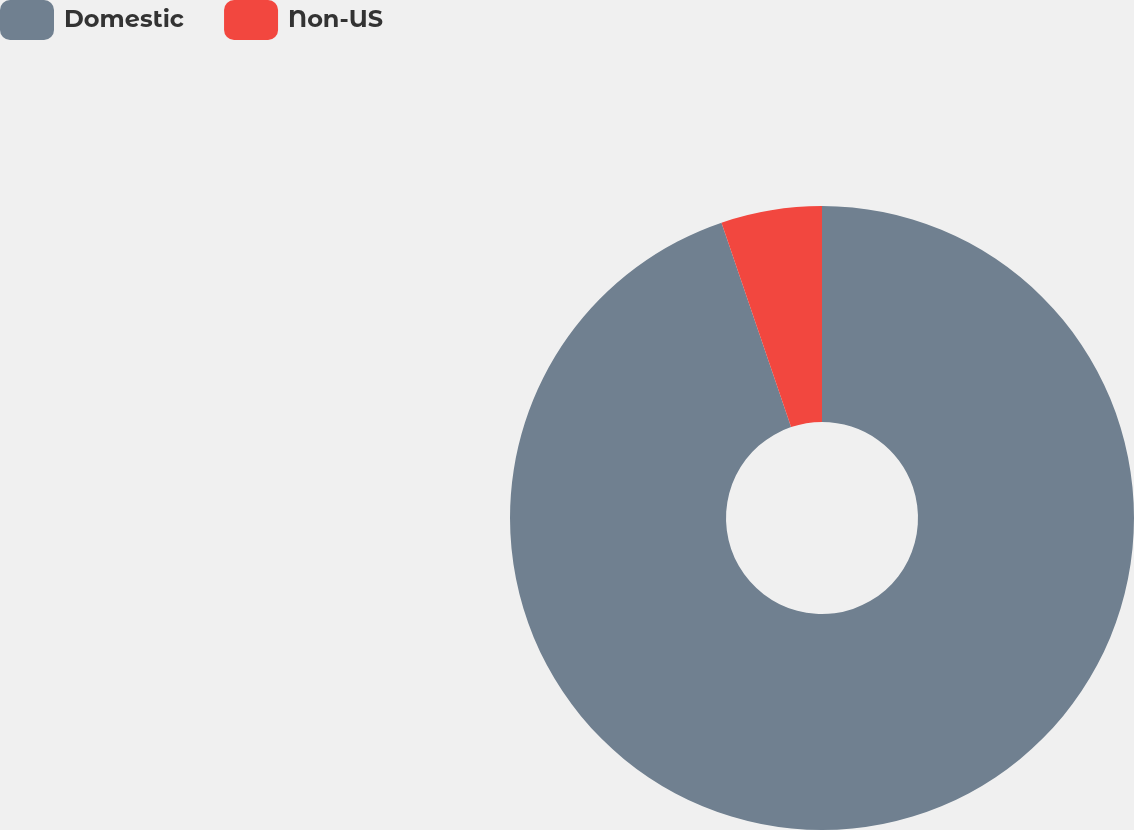Convert chart to OTSL. <chart><loc_0><loc_0><loc_500><loc_500><pie_chart><fcel>Domestic<fcel>Non-US<nl><fcel>94.78%<fcel>5.22%<nl></chart> 